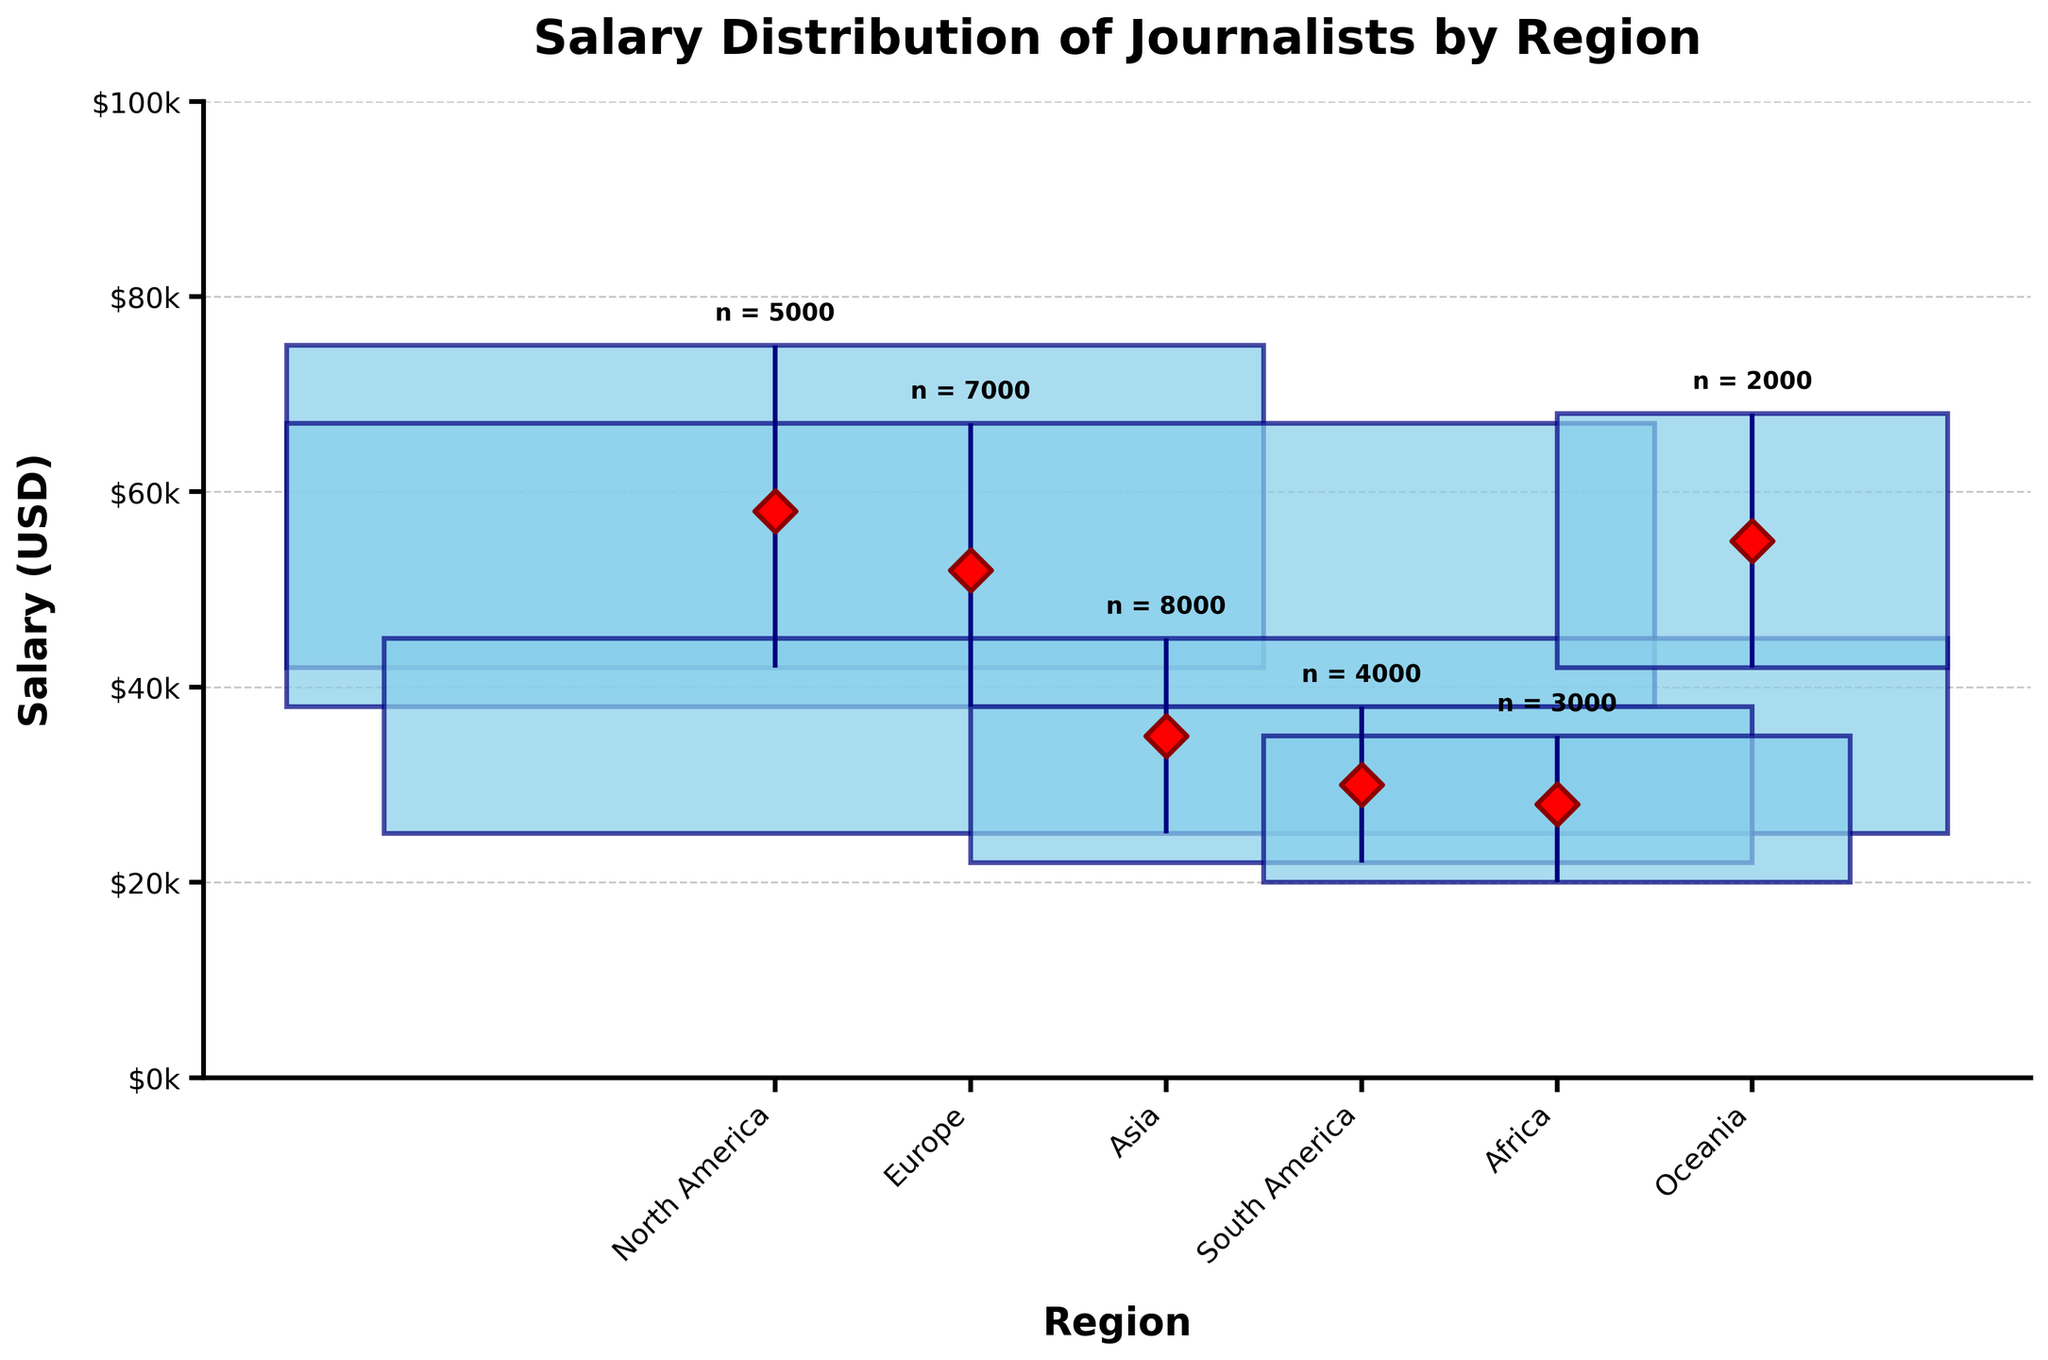What is the title of the plot? The title of the plot is usually positioned at the top and is meant to provide a summary of what the plot represents. The title of this plot reads 'Salary Distribution of Journalists by Region'.
Answer: Salary Distribution of Journalists by Region Which region has the highest median salary for journalists? The median salary is indicated by the red diamond shape in the plot. Among the regions, the highest median salary is for North America.
Answer: North America What is the median salary of journalists in Europe? The red diamond shape represents the median salary for each region. For Europe, it is marked next to the 'Europe' label. The median salary for journalists in Europe is $52,000.
Answer: $52,000 Which region has the least salary distribution range (Q3-Q1)? The salary distribution range is the difference between Q3 and Q1 (the top and bottom edges of the box). The smallest box represents the least range. For this plot, Oceania has the smallest range.
Answer: Oceania How many journalists are there in Asia? The size of each box reflects the number of journalists in that region. The annotation above the box provides the exact number. For Asia, the annotation reads 'n = 8000'.
Answer: 8000 What's the interquartile range (IQR) for journalists' salaries in South America? The IQR is calculated as Q3 - Q1. In South America, Q3 is $38,000 and Q1 is $22,000. Thus, the IQR is $38,000 - $22,000 = $16,000.
Answer: $16,000 Compare North America and Oceania in terms of journalists' median salary. Which region has a higher median salary? To determine which region has a higher median salary, we compare the red diamond shapes. The red diamond for North America is higher than that for Oceania. Therefore, North America has a higher median salary.
Answer: North America What is the maximum salary represented for journalists in Africa? The maximum salary isn't directly shown in this plot, but you can estimate it as slightly higher than Q3 for the highest data point. For Africa, Q3 is $35,000, so the maximum is slightly above that mark.
Answer: Slightly above $35,000 Which region has the widest salary distribution range? The widest salary distribution range is indicated by the largest gap between Q1 and Q3. For this plot, North America has the widest range (Q3-Q1).
Answer: North America Among the regions, which one has the second-highest number of journalists? By observing the annotations above each box, Asia has the highest number of journalists with 8000, followed by Europe with 7000.
Answer: Europe 